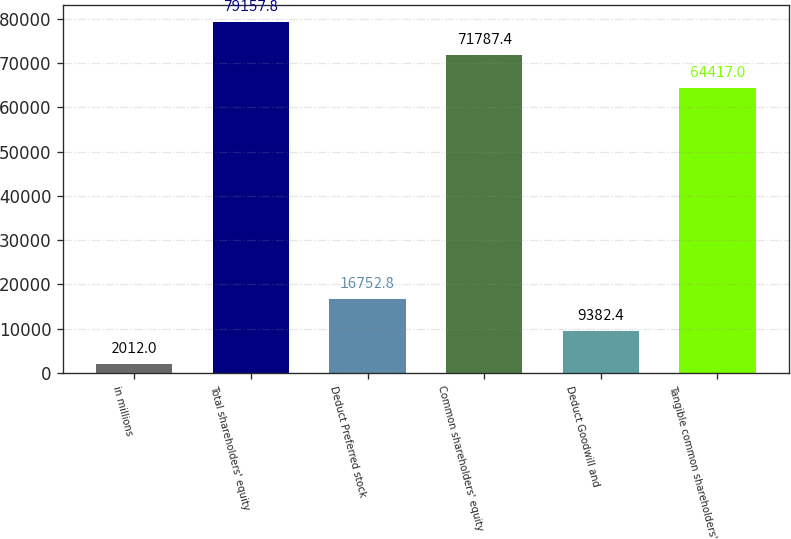Convert chart. <chart><loc_0><loc_0><loc_500><loc_500><bar_chart><fcel>in millions<fcel>Total shareholders' equity<fcel>Deduct Preferred stock<fcel>Common shareholders' equity<fcel>Deduct Goodwill and<fcel>Tangible common shareholders'<nl><fcel>2012<fcel>79157.8<fcel>16752.8<fcel>71787.4<fcel>9382.4<fcel>64417<nl></chart> 